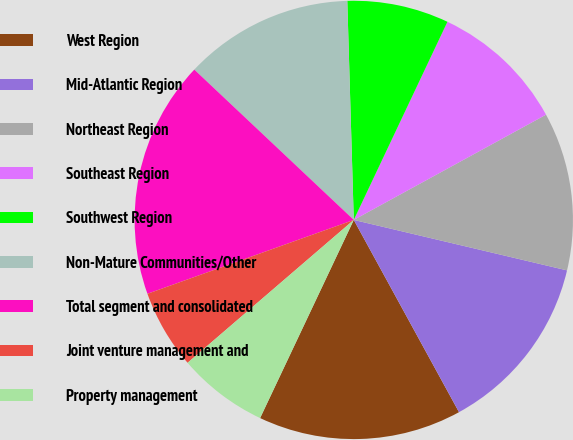<chart> <loc_0><loc_0><loc_500><loc_500><pie_chart><fcel>West Region<fcel>Mid-Atlantic Region<fcel>Northeast Region<fcel>Southeast Region<fcel>Southwest Region<fcel>Non-Mature Communities/Other<fcel>Total segment and consolidated<fcel>Joint venture management and<fcel>Property management<nl><fcel>15.0%<fcel>13.33%<fcel>11.67%<fcel>10.0%<fcel>7.5%<fcel>12.5%<fcel>17.5%<fcel>5.83%<fcel>6.67%<nl></chart> 